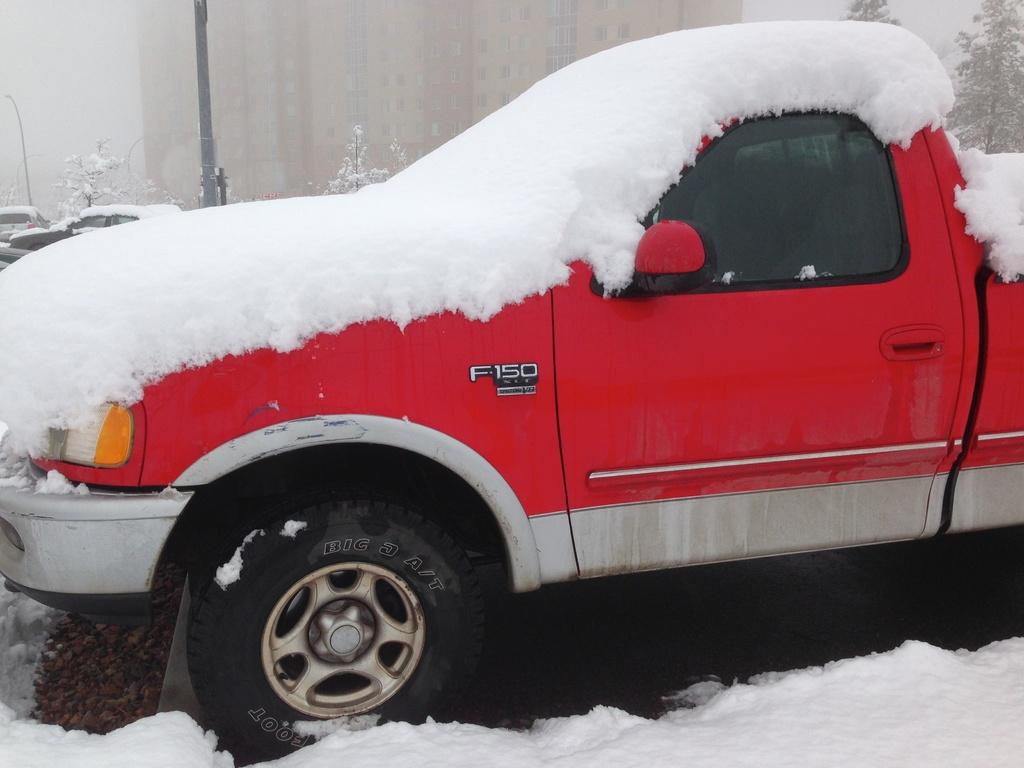What is the make of the truck?
Provide a succinct answer. F150. What is the word under f150 ?
Your answer should be compact. Unanswerable. 